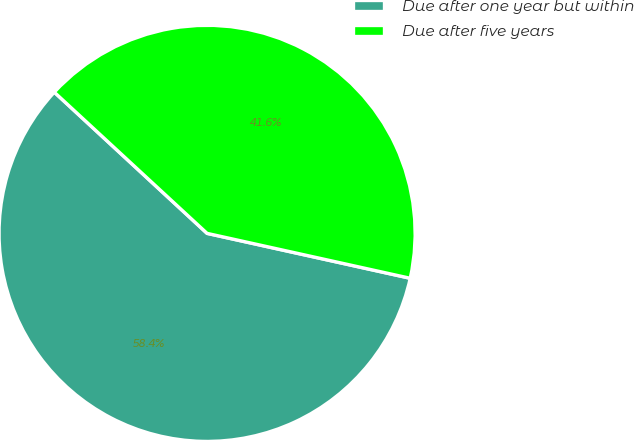<chart> <loc_0><loc_0><loc_500><loc_500><pie_chart><fcel>Due after one year but within<fcel>Due after five years<nl><fcel>58.41%<fcel>41.59%<nl></chart> 